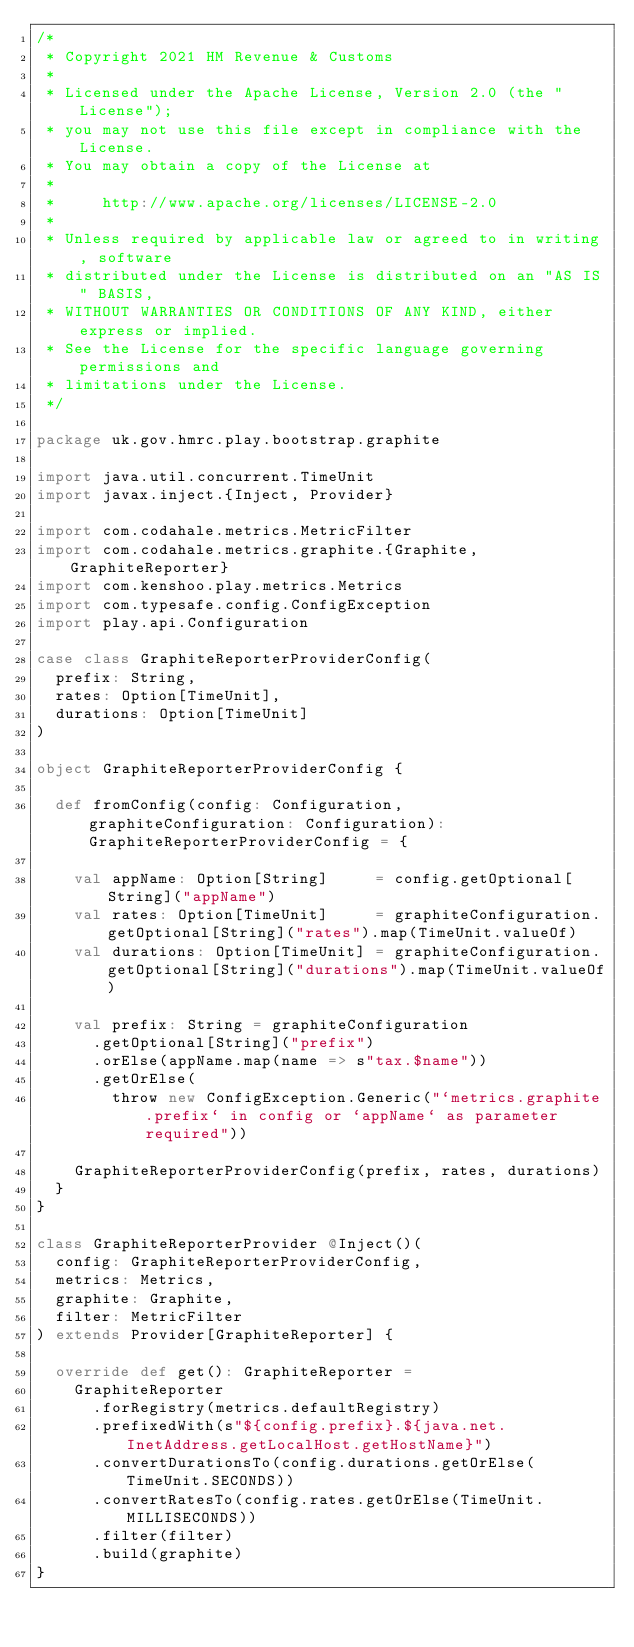Convert code to text. <code><loc_0><loc_0><loc_500><loc_500><_Scala_>/*
 * Copyright 2021 HM Revenue & Customs
 *
 * Licensed under the Apache License, Version 2.0 (the "License");
 * you may not use this file except in compliance with the License.
 * You may obtain a copy of the License at
 *
 *     http://www.apache.org/licenses/LICENSE-2.0
 *
 * Unless required by applicable law or agreed to in writing, software
 * distributed under the License is distributed on an "AS IS" BASIS,
 * WITHOUT WARRANTIES OR CONDITIONS OF ANY KIND, either express or implied.
 * See the License for the specific language governing permissions and
 * limitations under the License.
 */

package uk.gov.hmrc.play.bootstrap.graphite

import java.util.concurrent.TimeUnit
import javax.inject.{Inject, Provider}

import com.codahale.metrics.MetricFilter
import com.codahale.metrics.graphite.{Graphite, GraphiteReporter}
import com.kenshoo.play.metrics.Metrics
import com.typesafe.config.ConfigException
import play.api.Configuration

case class GraphiteReporterProviderConfig(
  prefix: String,
  rates: Option[TimeUnit],
  durations: Option[TimeUnit]
)

object GraphiteReporterProviderConfig {

  def fromConfig(config: Configuration, graphiteConfiguration: Configuration): GraphiteReporterProviderConfig = {

    val appName: Option[String]     = config.getOptional[String]("appName")
    val rates: Option[TimeUnit]     = graphiteConfiguration.getOptional[String]("rates").map(TimeUnit.valueOf)
    val durations: Option[TimeUnit] = graphiteConfiguration.getOptional[String]("durations").map(TimeUnit.valueOf)

    val prefix: String = graphiteConfiguration
      .getOptional[String]("prefix")
      .orElse(appName.map(name => s"tax.$name"))
      .getOrElse(
        throw new ConfigException.Generic("`metrics.graphite.prefix` in config or `appName` as parameter required"))

    GraphiteReporterProviderConfig(prefix, rates, durations)
  }
}

class GraphiteReporterProvider @Inject()(
  config: GraphiteReporterProviderConfig,
  metrics: Metrics,
  graphite: Graphite,
  filter: MetricFilter
) extends Provider[GraphiteReporter] {

  override def get(): GraphiteReporter =
    GraphiteReporter
      .forRegistry(metrics.defaultRegistry)
      .prefixedWith(s"${config.prefix}.${java.net.InetAddress.getLocalHost.getHostName}")
      .convertDurationsTo(config.durations.getOrElse(TimeUnit.SECONDS))
      .convertRatesTo(config.rates.getOrElse(TimeUnit.MILLISECONDS))
      .filter(filter)
      .build(graphite)
}
</code> 